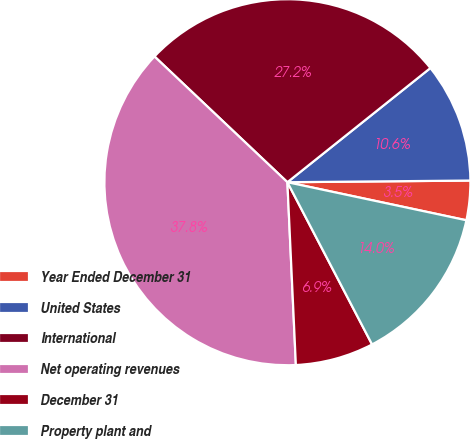Convert chart. <chart><loc_0><loc_0><loc_500><loc_500><pie_chart><fcel>Year Ended December 31<fcel>United States<fcel>International<fcel>Net operating revenues<fcel>December 31<fcel>Property plant and<nl><fcel>3.48%<fcel>10.58%<fcel>27.22%<fcel>37.8%<fcel>6.92%<fcel>14.01%<nl></chart> 